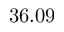Convert formula to latex. <formula><loc_0><loc_0><loc_500><loc_500>3 6 . 0 9</formula> 